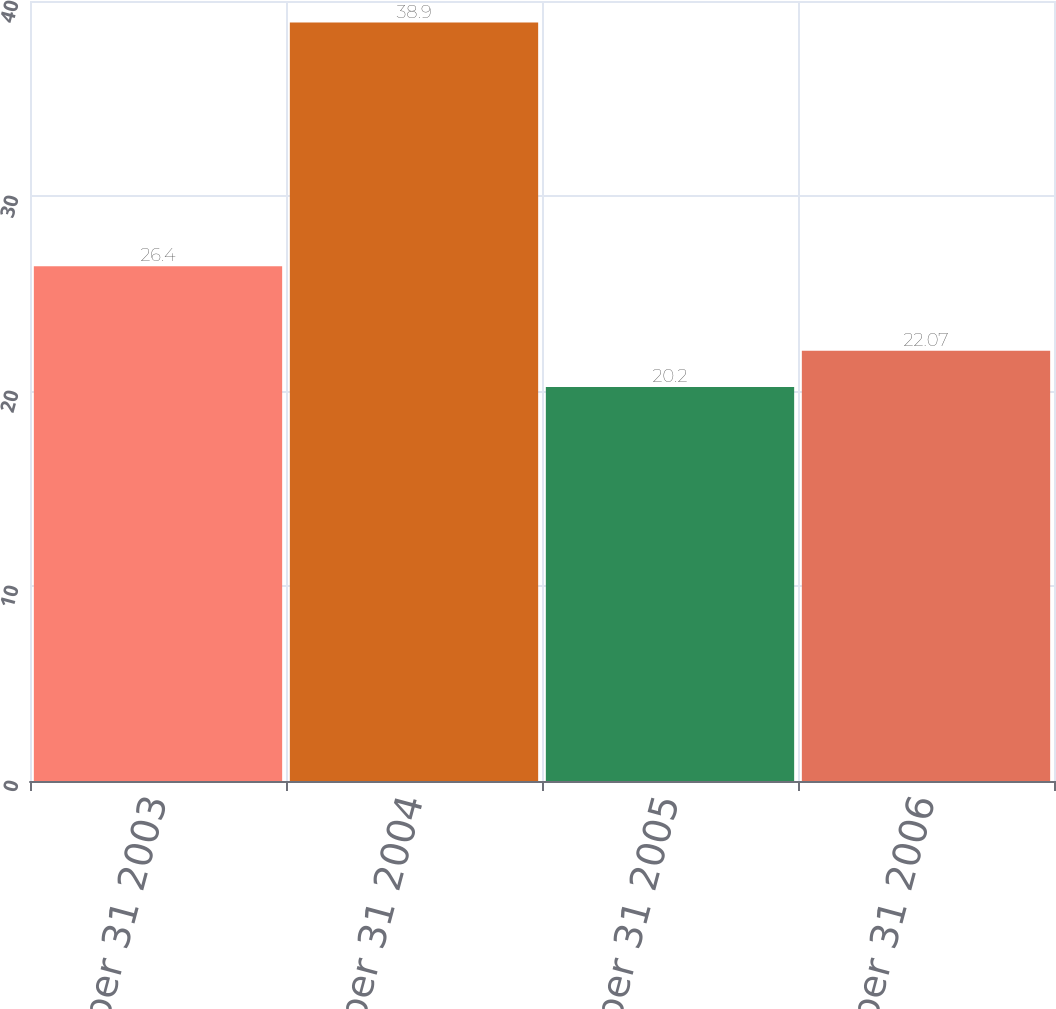Convert chart. <chart><loc_0><loc_0><loc_500><loc_500><bar_chart><fcel>December 31 2003<fcel>December 31 2004<fcel>December 31 2005<fcel>December 31 2006<nl><fcel>26.4<fcel>38.9<fcel>20.2<fcel>22.07<nl></chart> 